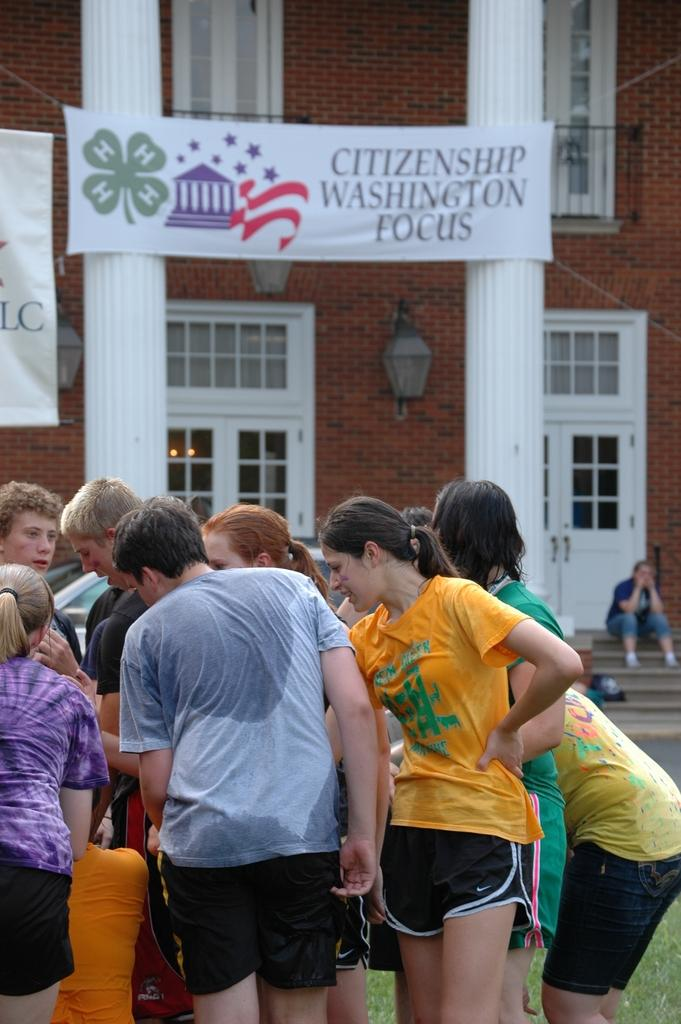What is happening with the group of people in the image? The group of people is on the ground. What can be seen in the background of the image? There is a building, pillars, banners, lights, a vehicle, and some objects in the background. What type of square is visible in the image? There is no square present in the image. What is the cause of the loss experienced by the people in the image? There is no indication of loss or any negative experience in the image. 